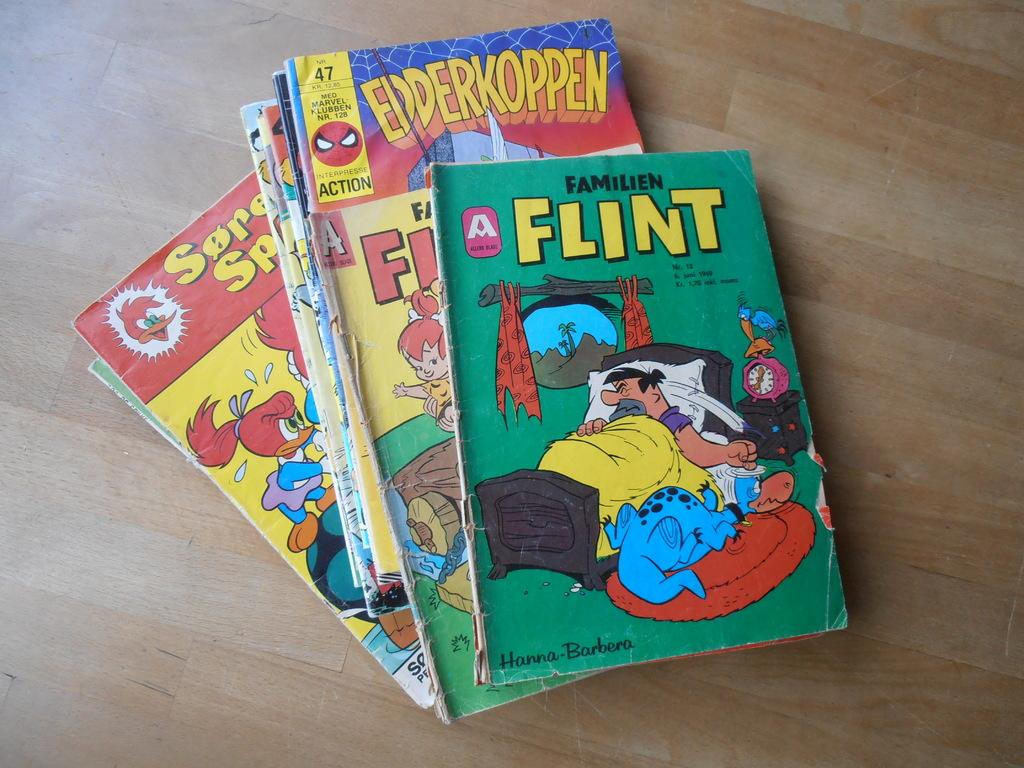<image>
Share a concise interpretation of the image provided. A stack of comic books written by Hanna-Barbera. 